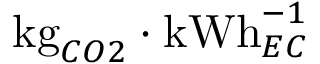Convert formula to latex. <formula><loc_0><loc_0><loc_500><loc_500>k g _ { C O 2 } \cdot k W h _ { E C } ^ { - 1 }</formula> 